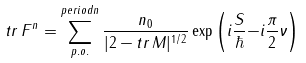Convert formula to latex. <formula><loc_0><loc_0><loc_500><loc_500>t r \, F ^ { n } = \sum _ { p . o . } ^ { p e r i o d n } \frac { n _ { 0 } } { | 2 - t r \, M | ^ { 1 / 2 } } \exp \left ( i \frac { S } { \hbar } { - } i \frac { \pi } { 2 } \nu \right )</formula> 